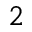Convert formula to latex. <formula><loc_0><loc_0><loc_500><loc_500>^ { 2 }</formula> 